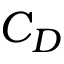Convert formula to latex. <formula><loc_0><loc_0><loc_500><loc_500>C _ { D }</formula> 